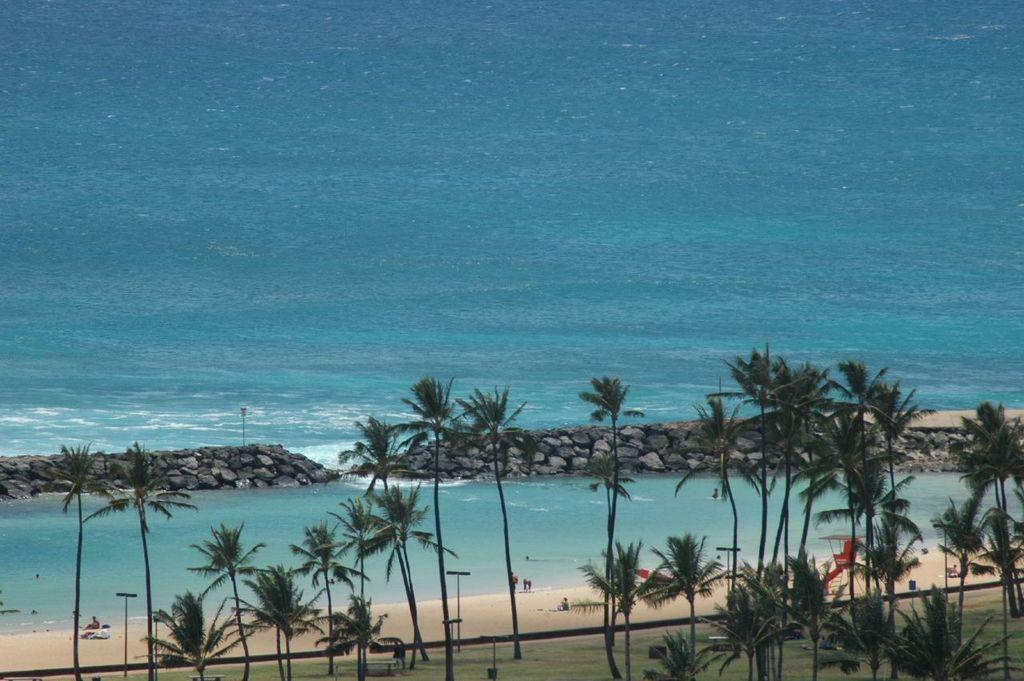What type of natural vegetation can be seen in the image? There are trees in the image. Who or what else is present in the image? There are people in the image. What type of ground surface is visible in the image? Pebbles are present in the image. What body of water can be seen in the image? There is water visible in the image. What type of location might the image depict? The image appears to depict a beach. What type of band can be seen playing music in the image? There is no band present in the image; it depicts a beach with trees, people, pebbles, water, and no musical instruments or performers. What type of loaf is visible in the image? There is no loaf present in the image; it depicts a beach with trees, people, pebbles, water, and no baked goods. 